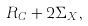<formula> <loc_0><loc_0><loc_500><loc_500>R _ { C } + 2 \Sigma _ { X } ,</formula> 